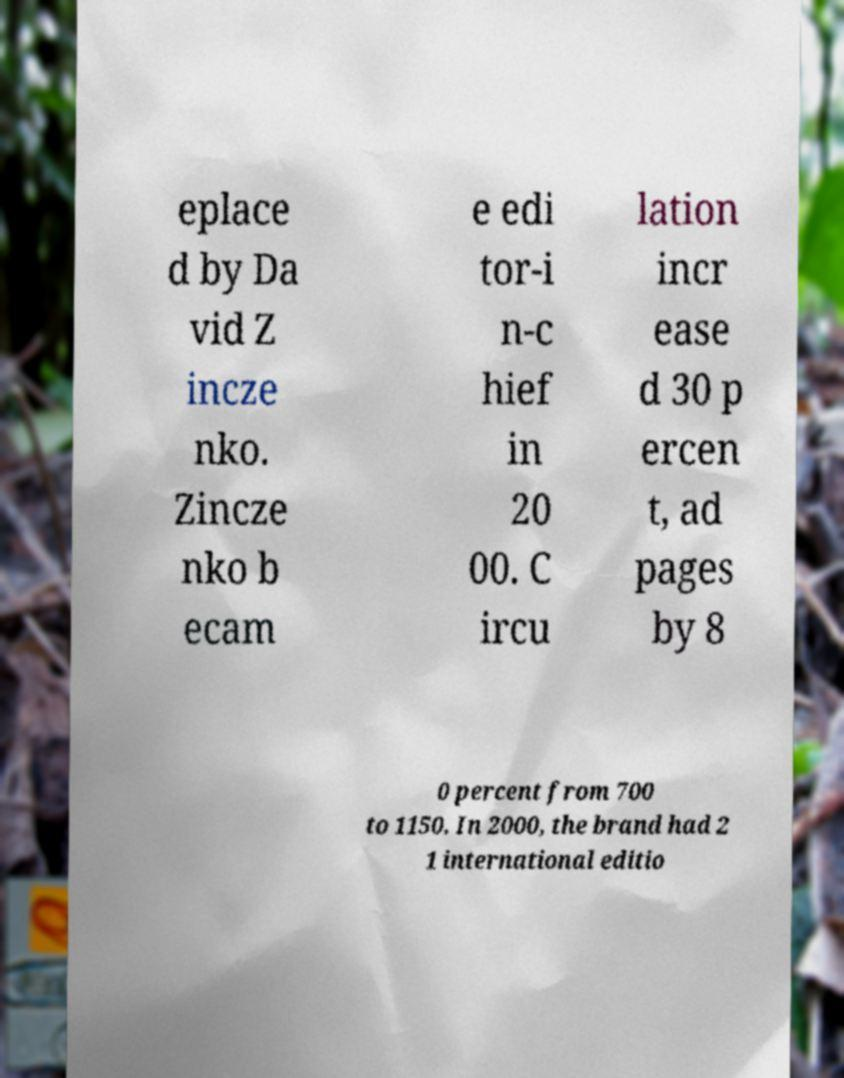Could you extract and type out the text from this image? eplace d by Da vid Z incze nko. Zincze nko b ecam e edi tor-i n-c hief in 20 00. C ircu lation incr ease d 30 p ercen t, ad pages by 8 0 percent from 700 to 1150. In 2000, the brand had 2 1 international editio 